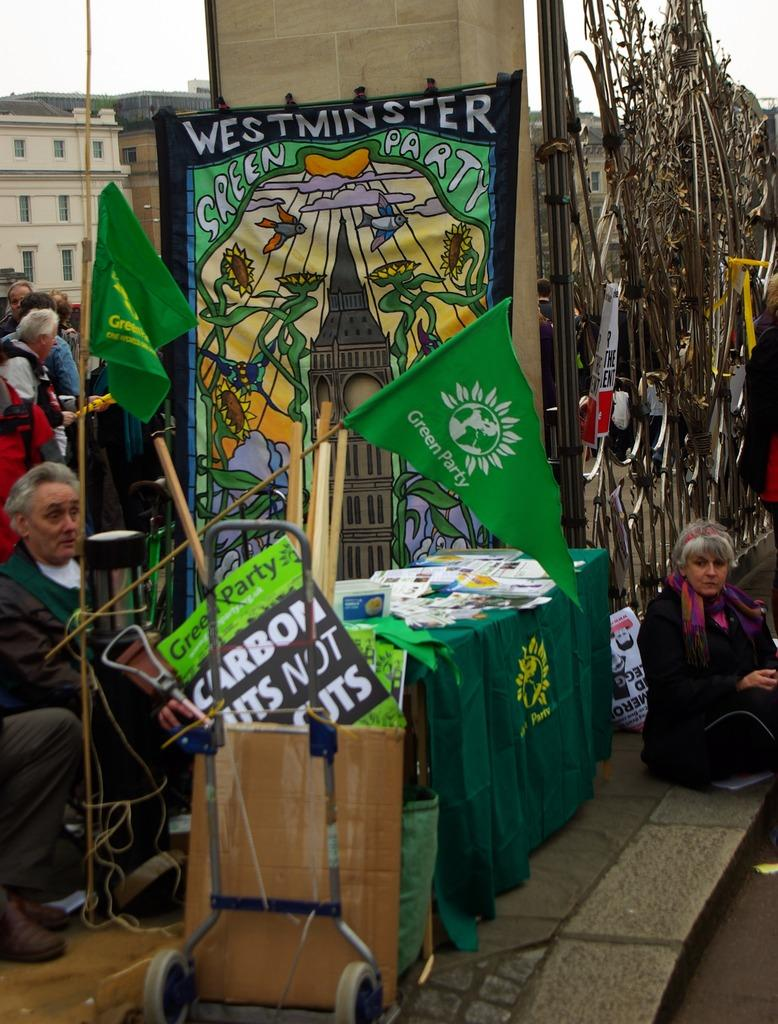What is happening on the road in the image? There is a group of people on the road in the image. What can be seen in addition to the people on the road? There are flags visible in the image. Can you describe any objects present in the image? Yes, there are objects present in the image. What can be seen in the background of the image? There are buildings and the sky visible in the background of the image. What type of quince is being used as a decoration in the image? There is no quince present in the image; it is not a decorative item or part of the scene. 